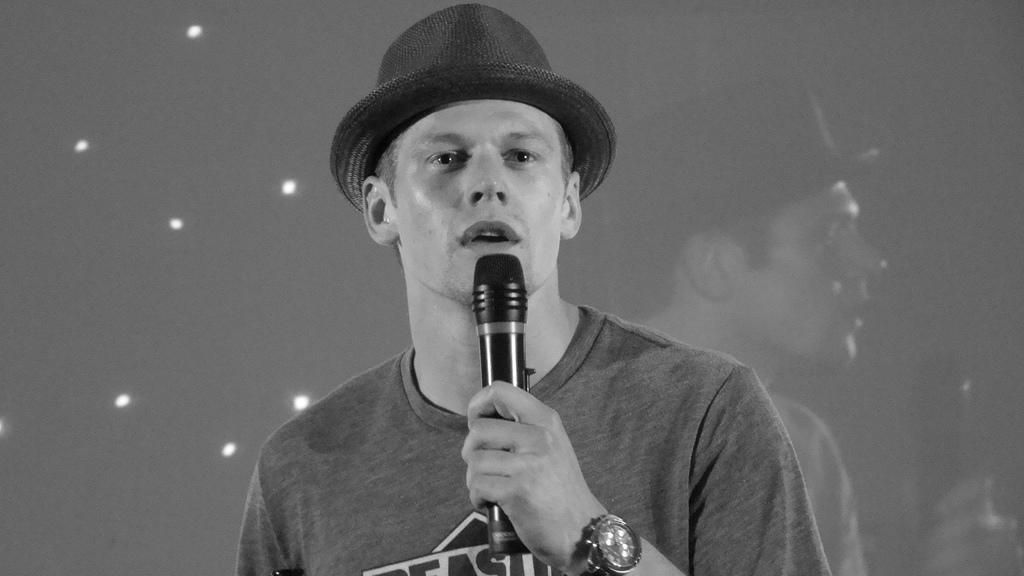What is the main subject of the image? The main subject of the image is a man. What is the man wearing on his upper body? The man is wearing a t-shirt. What is the man wearing on his head? The man is wearing a cap. What is the man holding in his hand? The man is holding a mic. What type of cart is the man using to sort his suits in the image? There is no cart or suits present in the image; the man is holding a mic. 